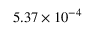<formula> <loc_0><loc_0><loc_500><loc_500>5 . 3 7 \times 1 0 ^ { - 4 }</formula> 